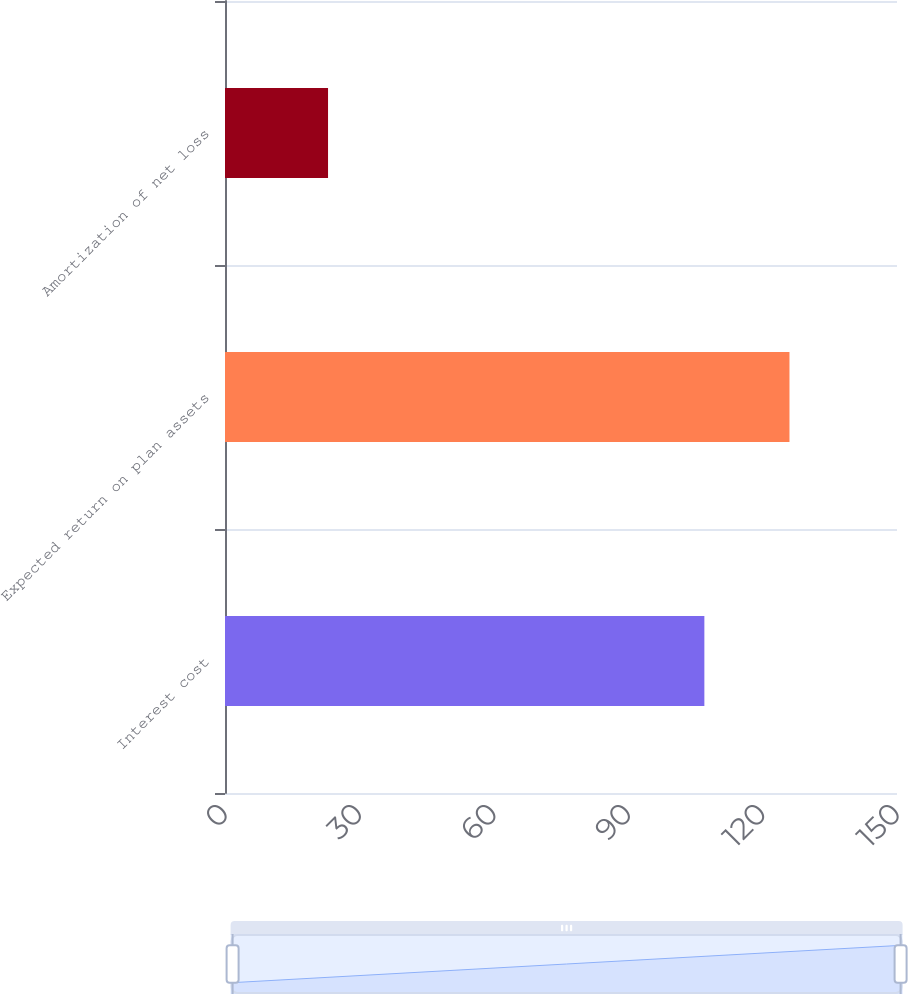<chart> <loc_0><loc_0><loc_500><loc_500><bar_chart><fcel>Interest cost<fcel>Expected return on plan assets<fcel>Amortization of net loss<nl><fcel>107<fcel>126<fcel>23<nl></chart> 